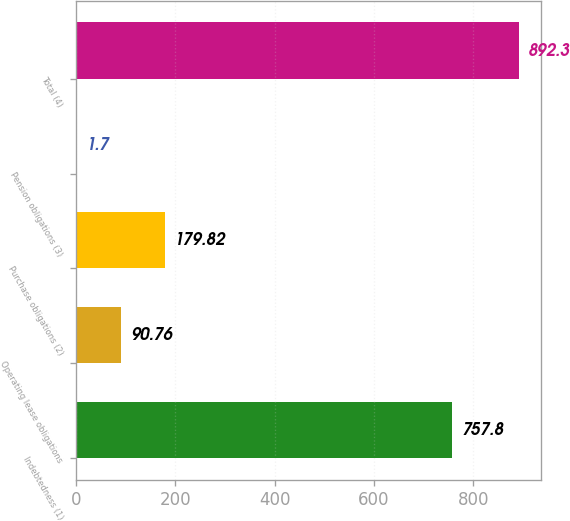Convert chart to OTSL. <chart><loc_0><loc_0><loc_500><loc_500><bar_chart><fcel>Indebtedness (1)<fcel>Operating lease obligations<fcel>Purchase obligations (2)<fcel>Pension obligations (3)<fcel>Total (4)<nl><fcel>757.8<fcel>90.76<fcel>179.82<fcel>1.7<fcel>892.3<nl></chart> 